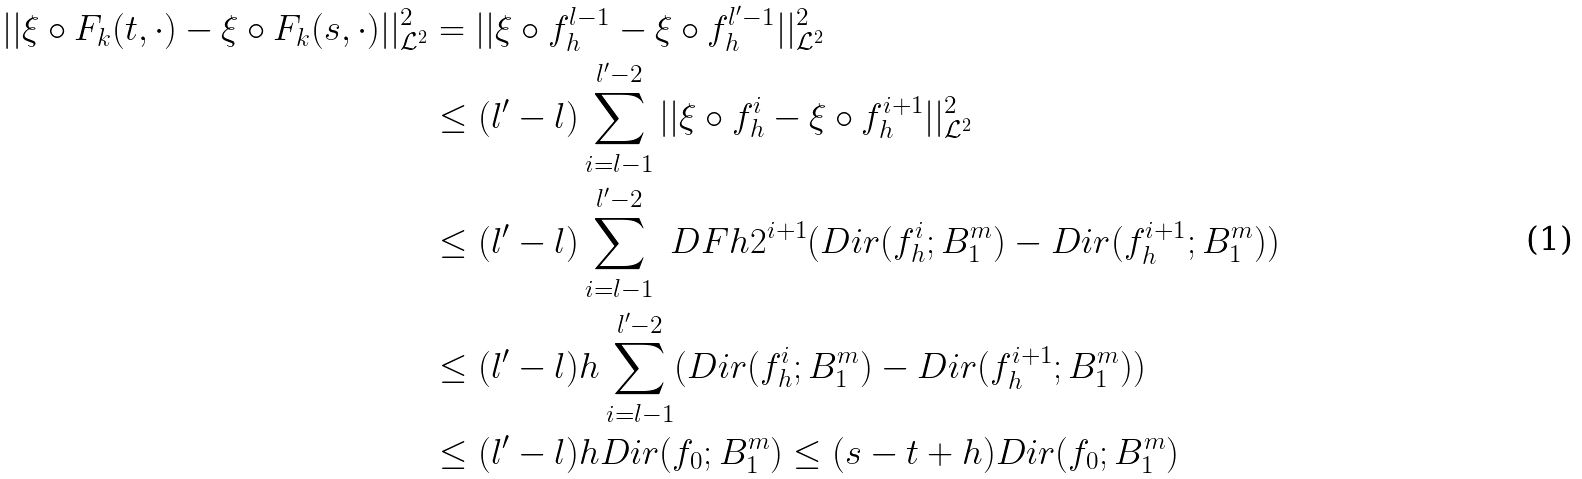Convert formula to latex. <formula><loc_0><loc_0><loc_500><loc_500>| | \xi \circ F _ { k } ( t , \cdot ) - \xi \circ F _ { k } ( s , \cdot ) | | _ { \mathcal { L } ^ { 2 } } ^ { 2 } & = | | \xi \circ f _ { h } ^ { l - 1 } - \xi \circ f _ { h } ^ { l ^ { \prime } - 1 } | | _ { \mathcal { L } ^ { 2 } } ^ { 2 } \\ & \leq ( l ^ { \prime } - l ) \sum _ { i = l - 1 } ^ { l ^ { \prime } - 2 } | | \xi \circ f _ { h } ^ { i } - \xi \circ f _ { h } ^ { i + 1 } | | _ { \mathcal { L } ^ { 2 } } ^ { 2 } \\ & \leq ( l ^ { \prime } - l ) \sum _ { i = l - 1 } ^ { l ^ { \prime } - 2 } \ D F { h } { 2 ^ { i + 1 } } ( D i r ( f _ { h } ^ { i } ; B _ { 1 } ^ { m } ) - D i r ( f _ { h } ^ { i + 1 } ; B _ { 1 } ^ { m } ) ) \\ & \leq ( l ^ { \prime } - l ) h \sum _ { i = l - 1 } ^ { l ^ { \prime } - 2 } ( D i r ( f _ { h } ^ { i } ; B _ { 1 } ^ { m } ) - D i r ( f _ { h } ^ { i + 1 } ; B _ { 1 } ^ { m } ) ) \\ & \leq ( l ^ { \prime } - l ) h D i r ( f _ { 0 } ; B _ { 1 } ^ { m } ) \leq ( s - t + h ) D i r ( f _ { 0 } ; B _ { 1 } ^ { m } )</formula> 